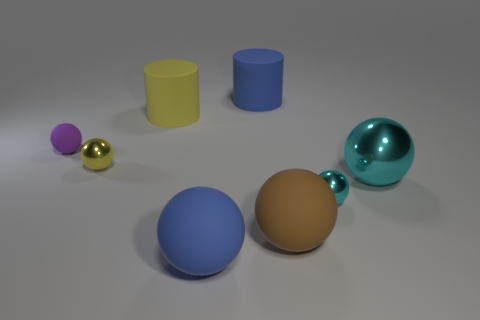Subtract all blue spheres. How many spheres are left? 5 Subtract all large blue spheres. How many spheres are left? 5 Add 3 large shiny balls. How many large shiny balls are left? 4 Add 5 large brown things. How many large brown things exist? 6 Add 2 purple objects. How many objects exist? 10 Subtract 0 purple cylinders. How many objects are left? 8 Subtract all cylinders. How many objects are left? 6 Subtract 6 balls. How many balls are left? 0 Subtract all blue spheres. Subtract all brown cubes. How many spheres are left? 5 Subtract all gray blocks. How many purple cylinders are left? 0 